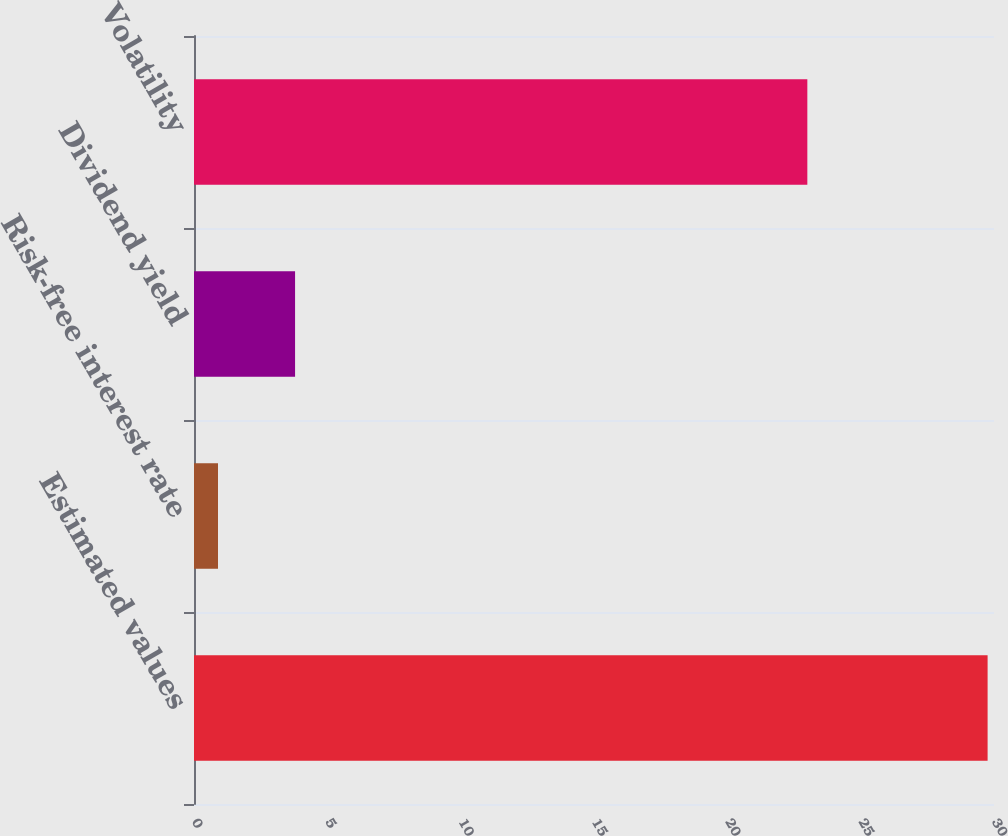<chart> <loc_0><loc_0><loc_500><loc_500><bar_chart><fcel>Estimated values<fcel>Risk-free interest rate<fcel>Dividend yield<fcel>Volatility<nl><fcel>29.76<fcel>0.9<fcel>3.79<fcel>23<nl></chart> 